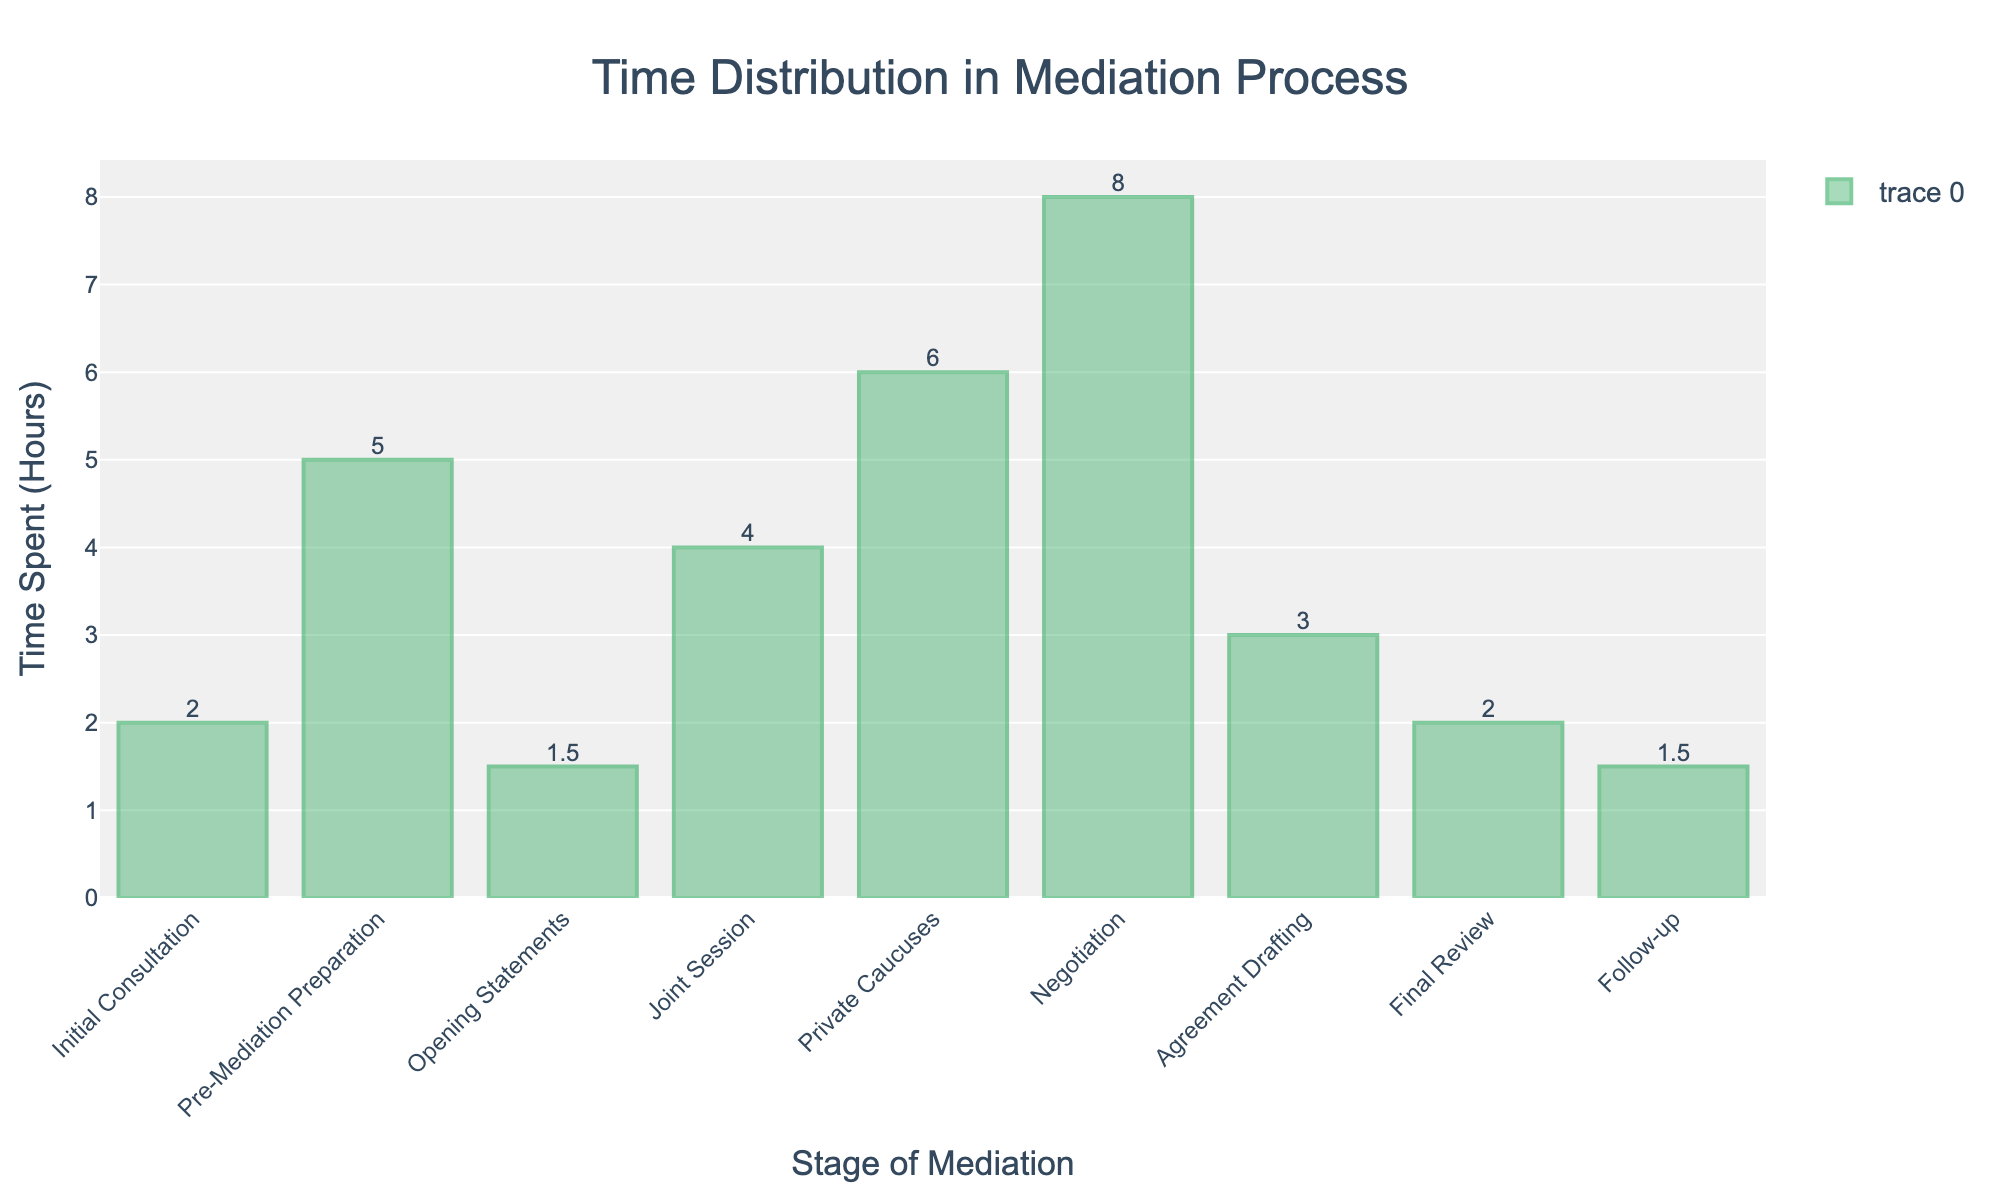Which stage of the mediation process takes the most time? The stage with the highest bar on the chart is the one that takes the most time. The "Negotiation" stage has the tallest bar.
Answer: Negotiation What is the total time spent on the initial consultation and follow-up stages combined? Add the time spent on the "Initial Consultation" and "Follow-up" stages: 2 hours for Initial Consultation + 1.5 hours for Follow-up = 3.5 hours.
Answer: 3.5 hours Which stage takes less time, the opening statements or the final review? Compare the height of the bars for "Opening Statements" and "Final Review". The "Opening Statements" stage takes 1.5 hours, and the "Final Review" stage takes 2 hours.
Answer: Opening Statements How much more time is spent in private caucuses compared to joint sessions? Subtract the time spent on "Joint Session" from the time spent on "Private Caucuses": 6 hours for Private Caucuses - 4 hours for Joint Session = 2 hours.
Answer: 2 hours List the stages that take less than 2 hours. Identify the bars that have a height less than 2 hours. These stages are "Initial Consultation", "Opening Statements", and "Follow-up".
Answer: Initial Consultation, Opening Statements, Follow-up What is the average time spent on the stages? Add up the time spent on all stages and divide by the number of stages. Total time is 2 + 5 + 1.5 + 4 + 6 + 8 + 3 + 2 + 1.5 = 33 hours. There are 9 stages. Average time = 33 / 9 = 3.67 hours.
Answer: 3.67 hours How much time is spent on pre-mediation preparation compared to agreement drafting? Compare the heights of the bars for "Pre-Mediation Preparation" and "Agreement Drafting". "Pre-Mediation Preparation" takes 5 hours, while "Agreement Drafting" takes 3 hours.
Answer: Pre-Mediation Preparation What is the sum of time spent on opening statements, joint session, and private caucuses? Add the time spent on "Opening Statements", "Joint Session", and "Private Caucuses": 1.5 + 4 + 6 = 11.5 hours.
Answer: 11.5 hours Which two stages take the same amount of time? Identify the bars with the same height. The "Opening Statements" and "Follow-up" stages both take 1.5 hours each.
Answer: Opening Statements, Follow-up How much more time is spent on agreement drafting than initial consultation? Subtract the time spent on "Initial Consultation" from the time spent on "Agreement Drafting": 3 hours for Agreement Drafting - 2 hours for Initial Consultation = 1 hour.
Answer: 1 hour 